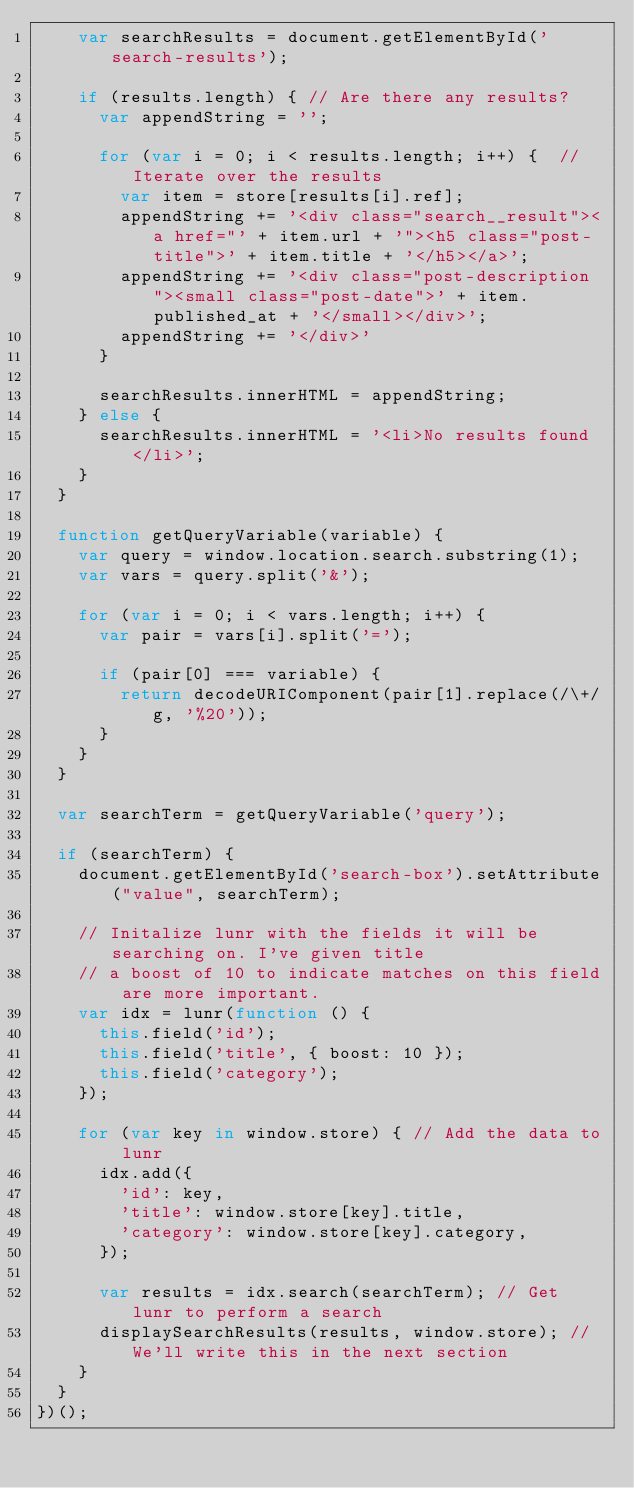Convert code to text. <code><loc_0><loc_0><loc_500><loc_500><_JavaScript_>    var searchResults = document.getElementById('search-results');

    if (results.length) { // Are there any results?
      var appendString = '';

      for (var i = 0; i < results.length; i++) {  // Iterate over the results
        var item = store[results[i].ref];
        appendString += '<div class="search__result"><a href="' + item.url + '"><h5 class="post-title">' + item.title + '</h5></a>';
        appendString += '<div class="post-description"><small class="post-date">' + item.published_at + '</small></div>';
        appendString += '</div>'
      }

      searchResults.innerHTML = appendString;
    } else {
      searchResults.innerHTML = '<li>No results found</li>';
    }
  }

  function getQueryVariable(variable) {
    var query = window.location.search.substring(1);
    var vars = query.split('&');

    for (var i = 0; i < vars.length; i++) {
      var pair = vars[i].split('=');

      if (pair[0] === variable) {
        return decodeURIComponent(pair[1].replace(/\+/g, '%20'));
      }
    }
  }

  var searchTerm = getQueryVariable('query');

  if (searchTerm) {
    document.getElementById('search-box').setAttribute("value", searchTerm);

    // Initalize lunr with the fields it will be searching on. I've given title
    // a boost of 10 to indicate matches on this field are more important.
    var idx = lunr(function () {
      this.field('id');
      this.field('title', { boost: 10 });
      this.field('category');
    });

    for (var key in window.store) { // Add the data to lunr
      idx.add({
        'id': key,
        'title': window.store[key].title,
        'category': window.store[key].category,
      });

      var results = idx.search(searchTerm); // Get lunr to perform a search
      displaySearchResults(results, window.store); // We'll write this in the next section
    }
  }
})();</code> 